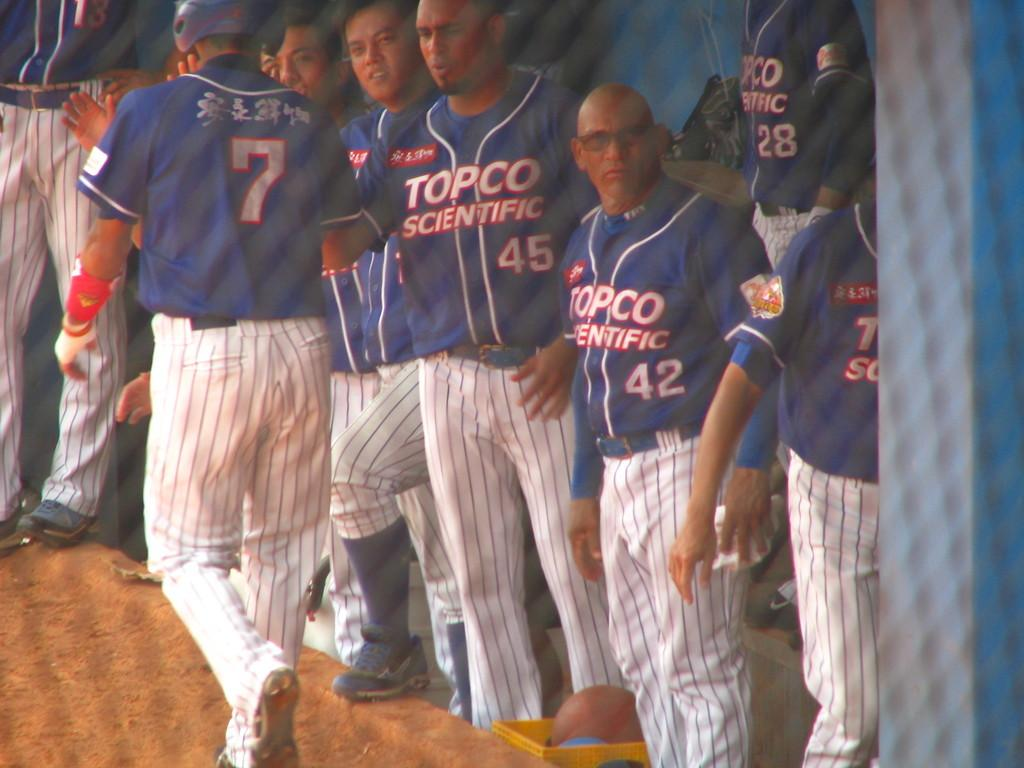<image>
Write a terse but informative summary of the picture. Baseball players wearing Topco Scientific baseball shirts stand in the dugout. 